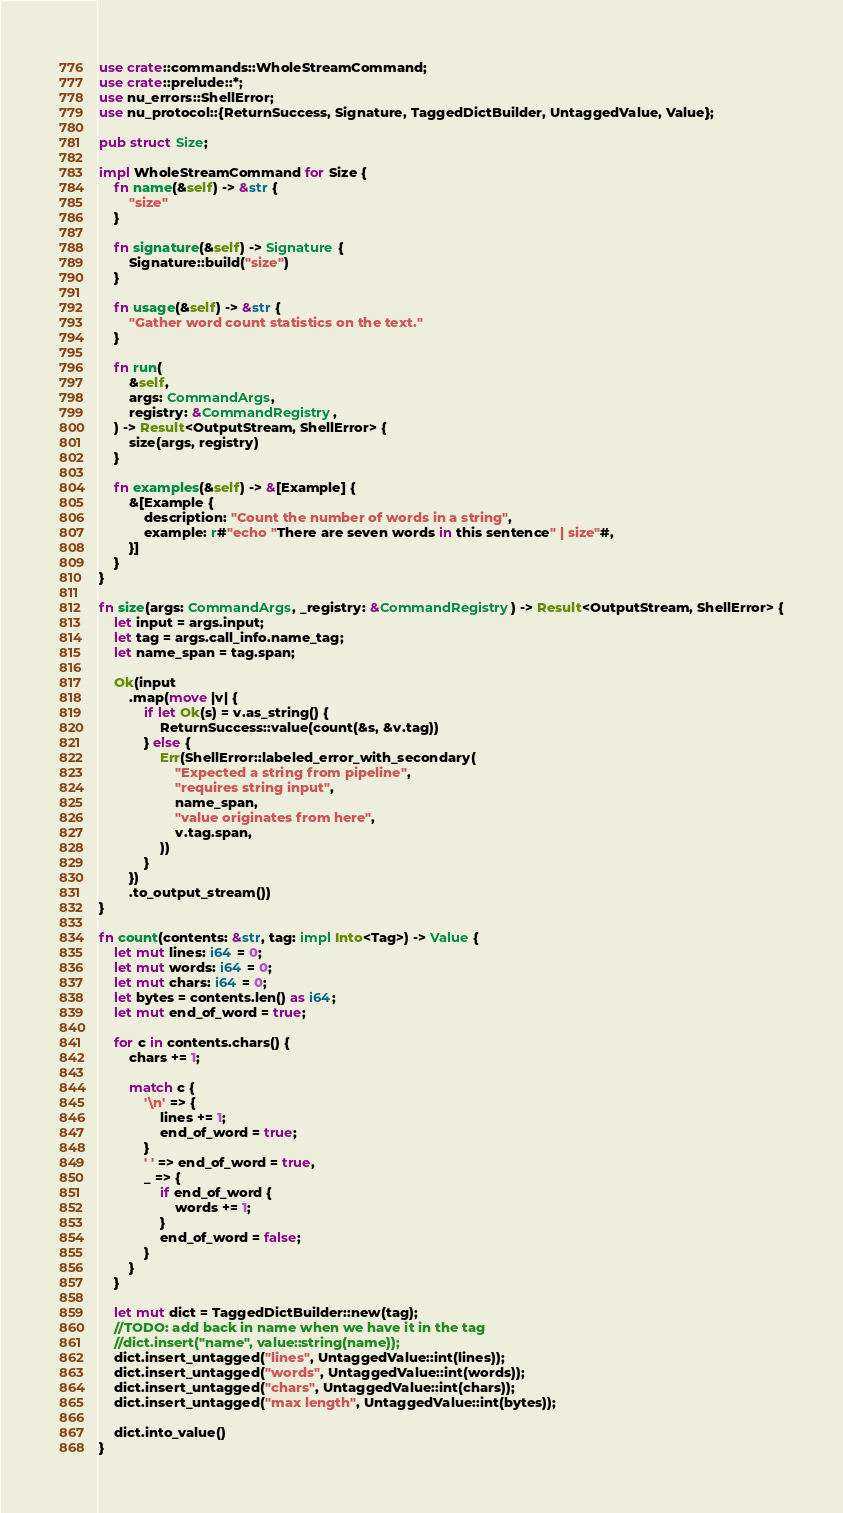Convert code to text. <code><loc_0><loc_0><loc_500><loc_500><_Rust_>use crate::commands::WholeStreamCommand;
use crate::prelude::*;
use nu_errors::ShellError;
use nu_protocol::{ReturnSuccess, Signature, TaggedDictBuilder, UntaggedValue, Value};

pub struct Size;

impl WholeStreamCommand for Size {
    fn name(&self) -> &str {
        "size"
    }

    fn signature(&self) -> Signature {
        Signature::build("size")
    }

    fn usage(&self) -> &str {
        "Gather word count statistics on the text."
    }

    fn run(
        &self,
        args: CommandArgs,
        registry: &CommandRegistry,
    ) -> Result<OutputStream, ShellError> {
        size(args, registry)
    }

    fn examples(&self) -> &[Example] {
        &[Example {
            description: "Count the number of words in a string",
            example: r#"echo "There are seven words in this sentence" | size"#,
        }]
    }
}

fn size(args: CommandArgs, _registry: &CommandRegistry) -> Result<OutputStream, ShellError> {
    let input = args.input;
    let tag = args.call_info.name_tag;
    let name_span = tag.span;

    Ok(input
        .map(move |v| {
            if let Ok(s) = v.as_string() {
                ReturnSuccess::value(count(&s, &v.tag))
            } else {
                Err(ShellError::labeled_error_with_secondary(
                    "Expected a string from pipeline",
                    "requires string input",
                    name_span,
                    "value originates from here",
                    v.tag.span,
                ))
            }
        })
        .to_output_stream())
}

fn count(contents: &str, tag: impl Into<Tag>) -> Value {
    let mut lines: i64 = 0;
    let mut words: i64 = 0;
    let mut chars: i64 = 0;
    let bytes = contents.len() as i64;
    let mut end_of_word = true;

    for c in contents.chars() {
        chars += 1;

        match c {
            '\n' => {
                lines += 1;
                end_of_word = true;
            }
            ' ' => end_of_word = true,
            _ => {
                if end_of_word {
                    words += 1;
                }
                end_of_word = false;
            }
        }
    }

    let mut dict = TaggedDictBuilder::new(tag);
    //TODO: add back in name when we have it in the tag
    //dict.insert("name", value::string(name));
    dict.insert_untagged("lines", UntaggedValue::int(lines));
    dict.insert_untagged("words", UntaggedValue::int(words));
    dict.insert_untagged("chars", UntaggedValue::int(chars));
    dict.insert_untagged("max length", UntaggedValue::int(bytes));

    dict.into_value()
}
</code> 